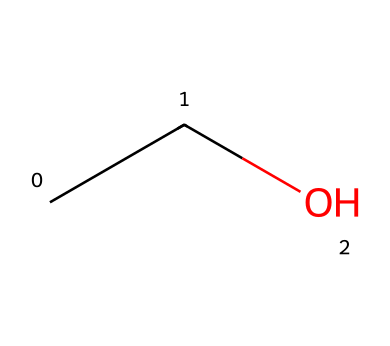What is the molecular formula for ethanol? The molecular formula can be derived from the SMILES representation (CCO) by counting the number of carbon (C), hydrogen (H), and oxygen (O) atoms. There are 2 carbon atoms, 6 hydrogen atoms, and 1 oxygen atom, giving the formula C2H6O.
Answer: C2H6O How many carbon atoms are in ethanol? The SMILES representation (CCO) indicates that there are two 'C' atoms, each representing a carbon atom, so there are two carbon atoms in ethanol.
Answer: 2 Is ethanol classified as an alcohol? Ethanol contains a hydroxyl group (-OH) attached to a carbon atom, which is the defining feature of alcohols. Thus, ethanol is classified as an alcohol.
Answer: yes What type of functional group is present in ethanol? The hydroxyl group (-OH) in the ethanol structure indicates its status as an alcohol, which is its key functional group.
Answer: hydroxyl How many total atoms are in the ethanol molecule? Counting all the atoms in the molecular formula C2H6O, we have 2 carbon, 6 hydrogen, and 1 oxygen, totaling 9 atoms.
Answer: 9 What is the degree of saturation in ethanol? The degree of saturation can be determined by the presence of double or triple bonds; however, ethanol has only single bonds (and a hydroxyl group), showing it is saturated. Thus, the degree of saturation is 1.
Answer: 1 Does ethanol contain any double bonds? Examining the hydrocarbon structure, ethanol is entirely made up of single bonds (C-C and C-O), which means it does not contain any double bonds.
Answer: no 